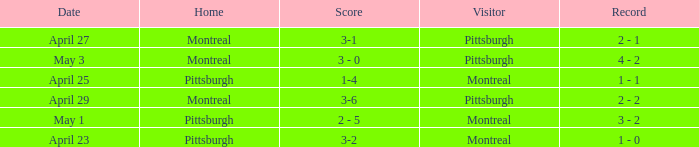What was the score on April 25? 1-4. 